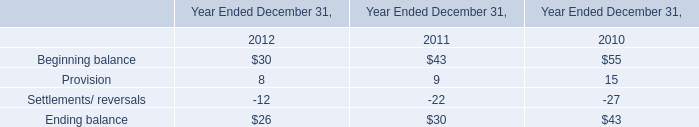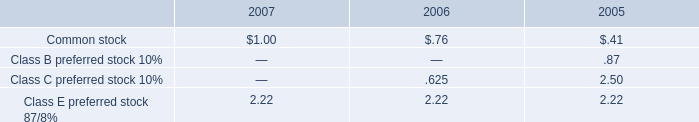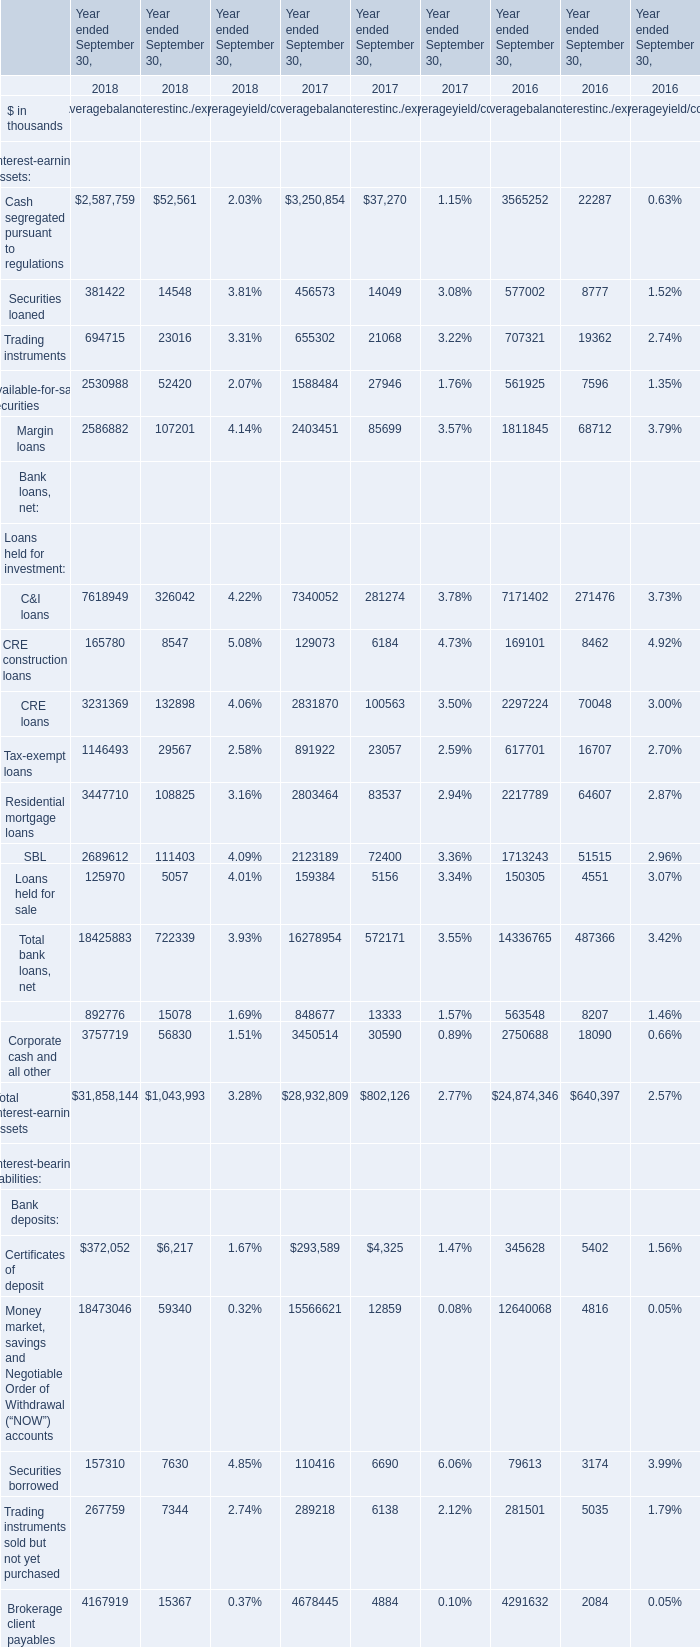what was the percent of the change in the amortization of deferred financing costs from 2006 to 2007 
Computations: ((13 - 15) / 15)
Answer: -0.13333. 